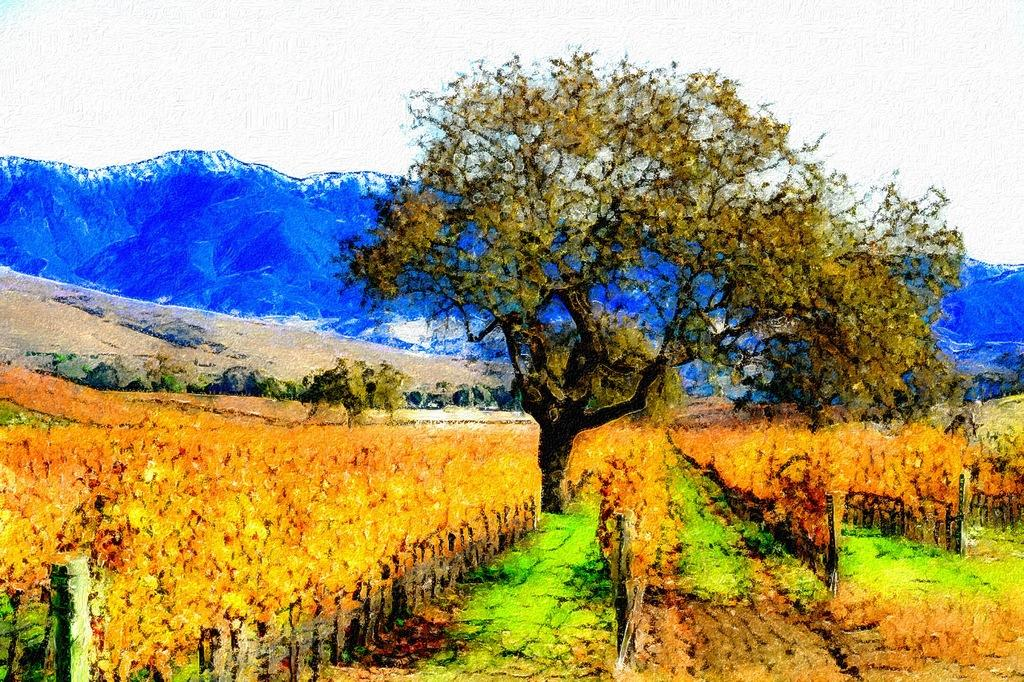What type of artwork is depicted in the image? The image is a painting. What natural elements are present in the painting? There are trees in the painting. What man-made structure can be seen in the painting? There is a fence in the painting. What type of landscape is visible in the background of the painting? There are hills in the background of the painting. What part of the natural environment is visible in the background of the painting? The sky is visible in the background of the painting. How many bats are resting on the fence in the painting? There are no bats present in the painting; it only features trees, a fence, hills, and the sky. 